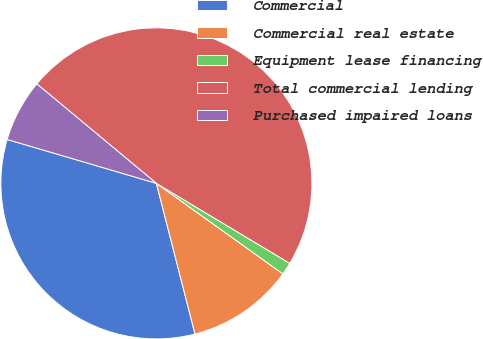<chart> <loc_0><loc_0><loc_500><loc_500><pie_chart><fcel>Commercial<fcel>Commercial real estate<fcel>Equipment lease financing<fcel>Total commercial lending<fcel>Purchased impaired loans<nl><fcel>33.55%<fcel>11.12%<fcel>1.29%<fcel>47.56%<fcel>6.49%<nl></chart> 